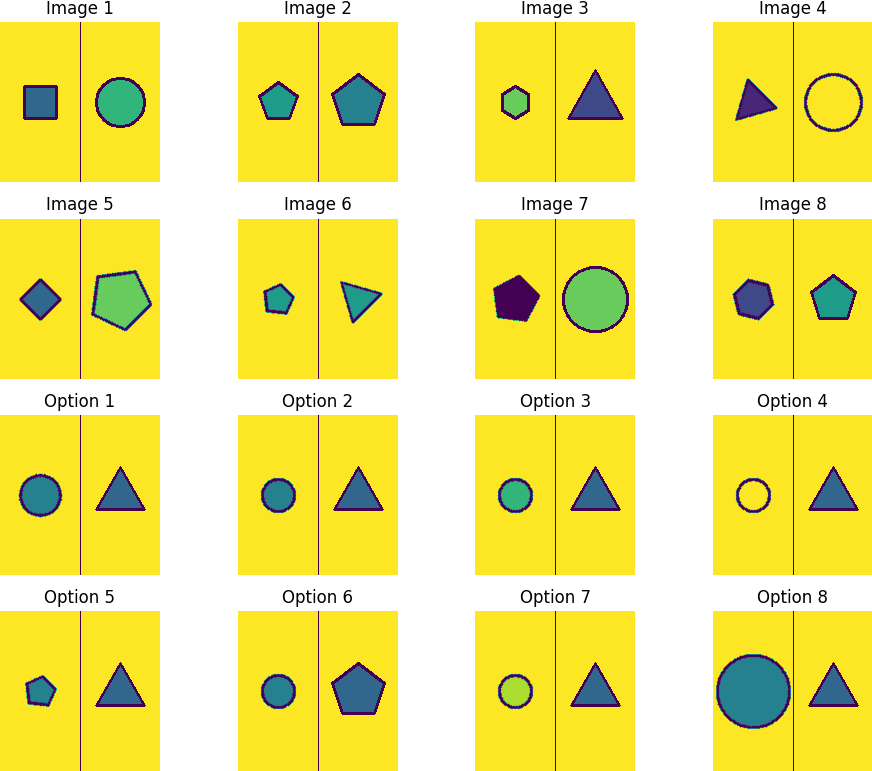Each image has 8 images labeled as Image 1 to Image 8. These 8 images follow a specific pattern. Detect the pattern and select the next image in the sequence from the 8 available options. The task of identifying the next image in the sequence requires careful observation of patterns in shape and color. Let's break this down:

1. Shape Rotation: The shapes follow a specific order - a square, circle, pentagon, triangle, and then the sequence repeats.
2. Color Variation: The fill color of shapes changes progressively through blue, purple, and green.
3. Border Color Change: The border alternates between dark blue, red, and light blue.

Following these insights, after the purple triangle (Image 6), a blue circle appears (Image 7). Continuing this pattern, the next shape should be a green polygon with five sides (pentagon) with a light blue border. Hence, the next image in the sequence would be a pentagon that is Option 4. 